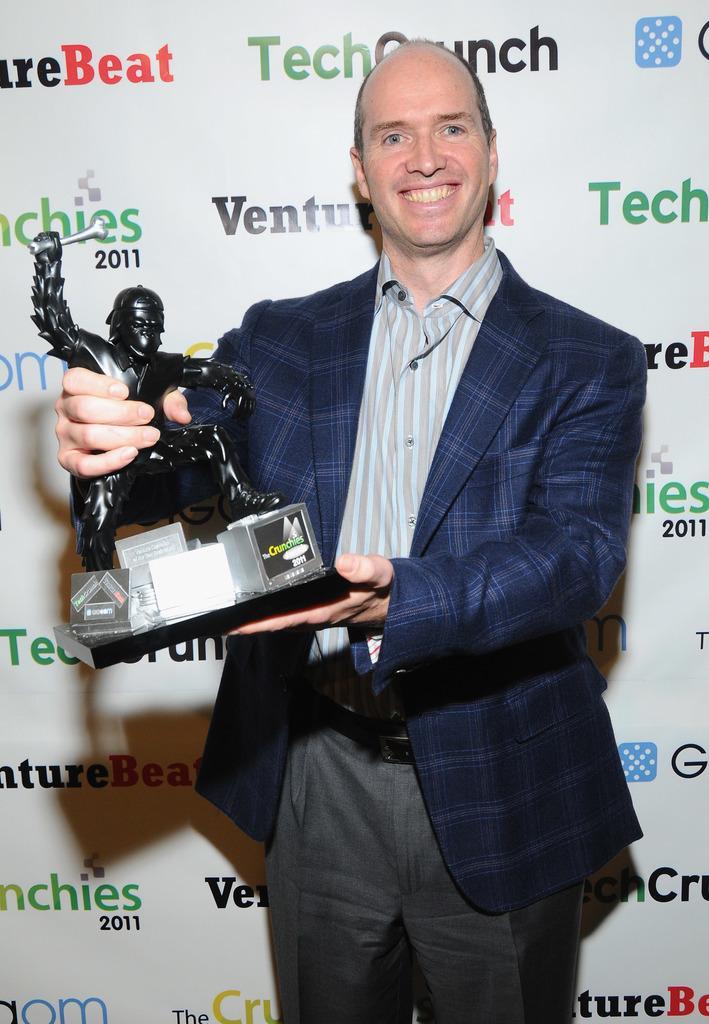Please provide a concise description of this image. In this image I can see a man is standing and I can see he is holding a black colour thing. I can also see he is wearing formal dress and I can see smile on his face. In the background I can see something is written at many places. 